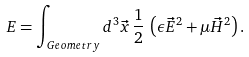Convert formula to latex. <formula><loc_0><loc_0><loc_500><loc_500>E = \int _ { G e o m e t r y } d ^ { 3 } \vec { x } \, \frac { 1 } { 2 } \, \left ( \epsilon \vec { E } ^ { 2 } + \mu \vec { H } ^ { 2 } \right ) .</formula> 